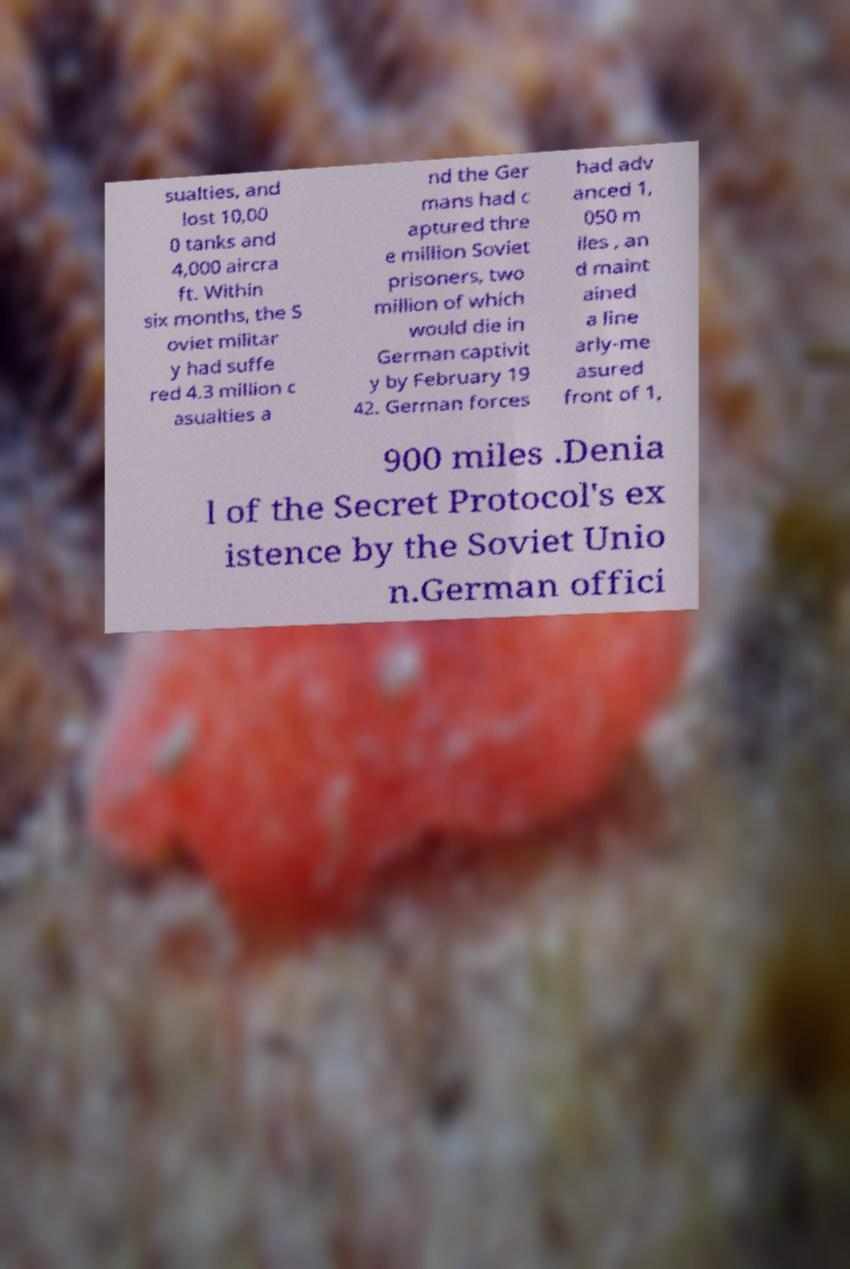Could you extract and type out the text from this image? sualties, and lost 10,00 0 tanks and 4,000 aircra ft. Within six months, the S oviet militar y had suffe red 4.3 million c asualties a nd the Ger mans had c aptured thre e million Soviet prisoners, two million of which would die in German captivit y by February 19 42. German forces had adv anced 1, 050 m iles , an d maint ained a line arly-me asured front of 1, 900 miles .Denia l of the Secret Protocol's ex istence by the Soviet Unio n.German offici 